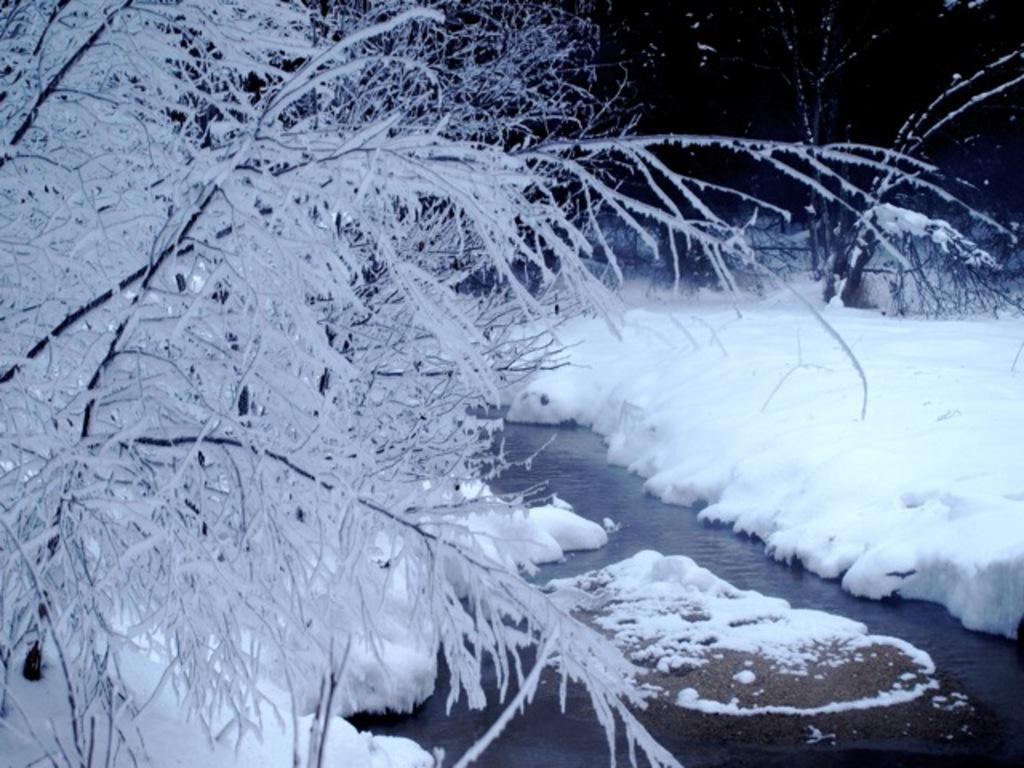What is located in the center of the image? There are trees in the center of the image. What natural element can be seen in the image? There is water visible in the image. What type of weather condition is depicted in the image? There is snow in the image. What type of glove can be seen in the image? There is no glove present in the image. 